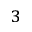Convert formula to latex. <formula><loc_0><loc_0><loc_500><loc_500>_ { 3 }</formula> 